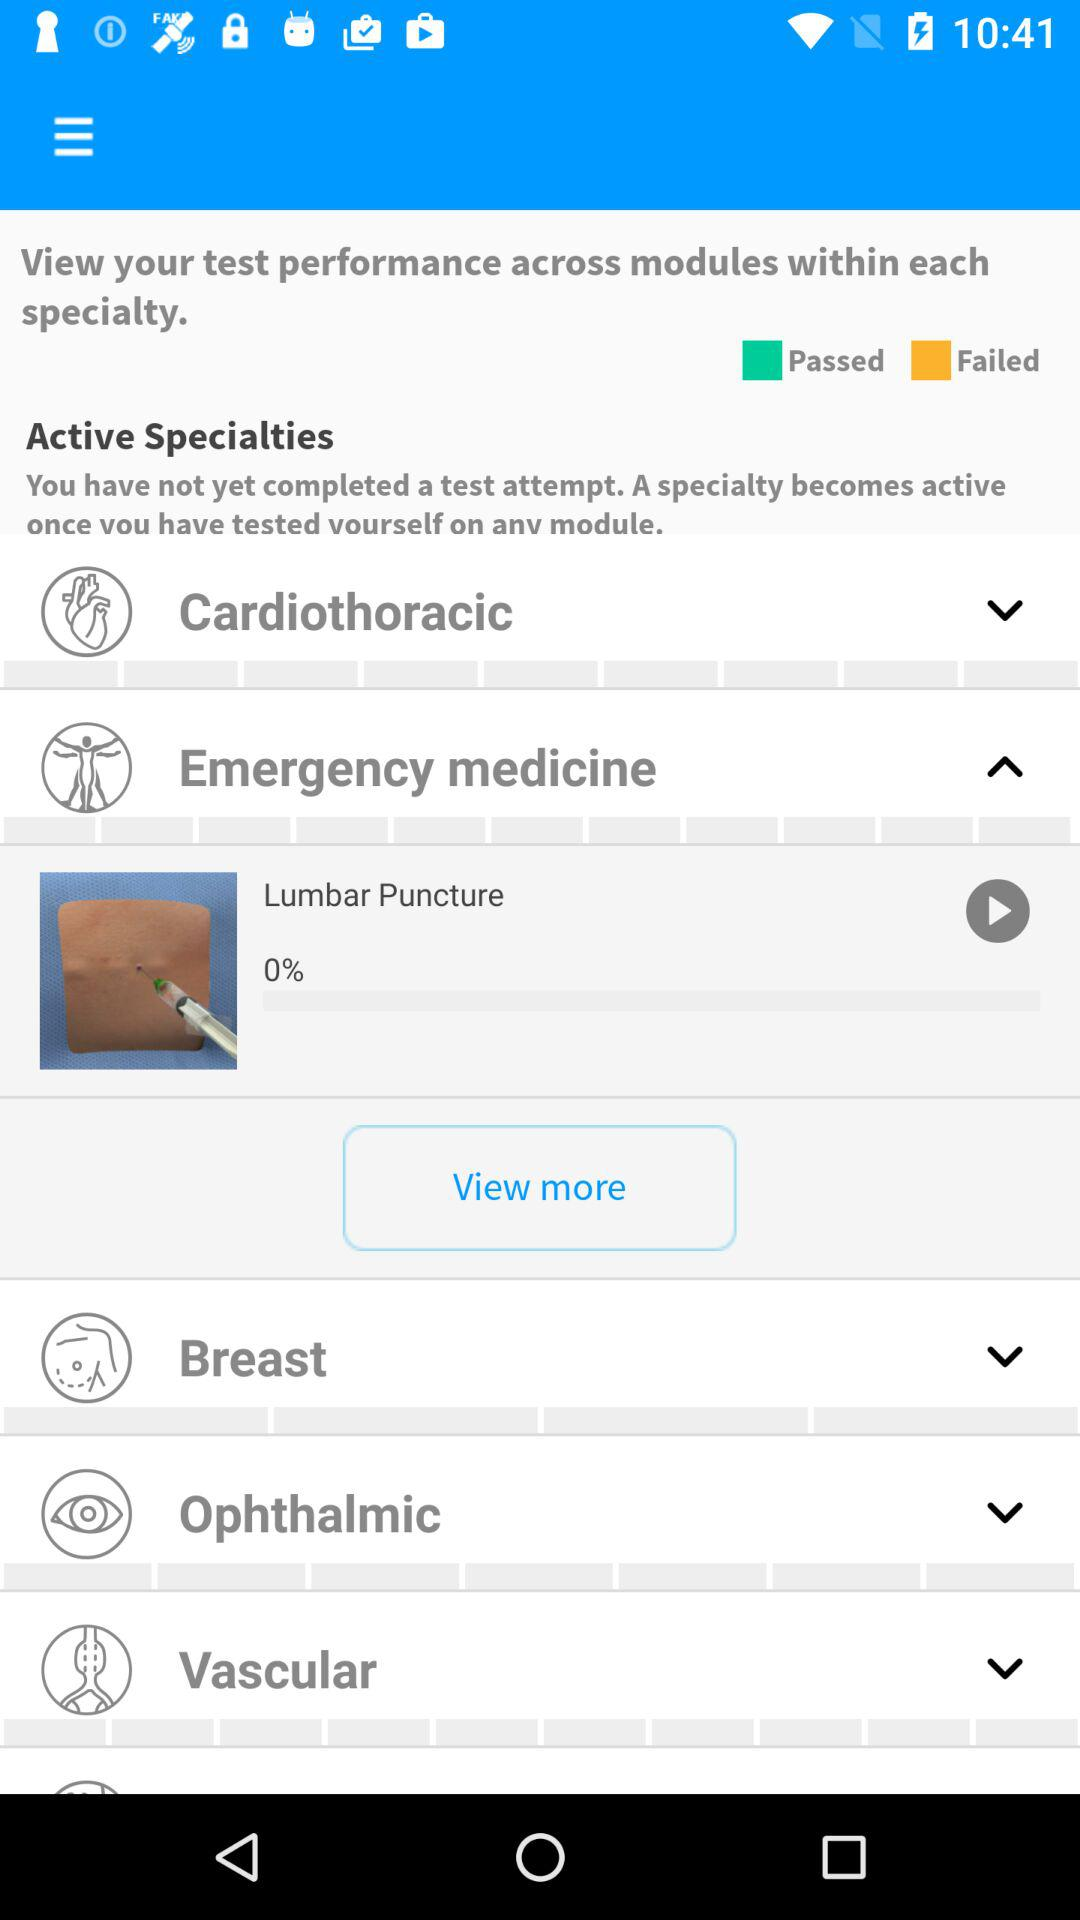Which tab is currently active?
When the provided information is insufficient, respond with <no answer>. <no answer> 